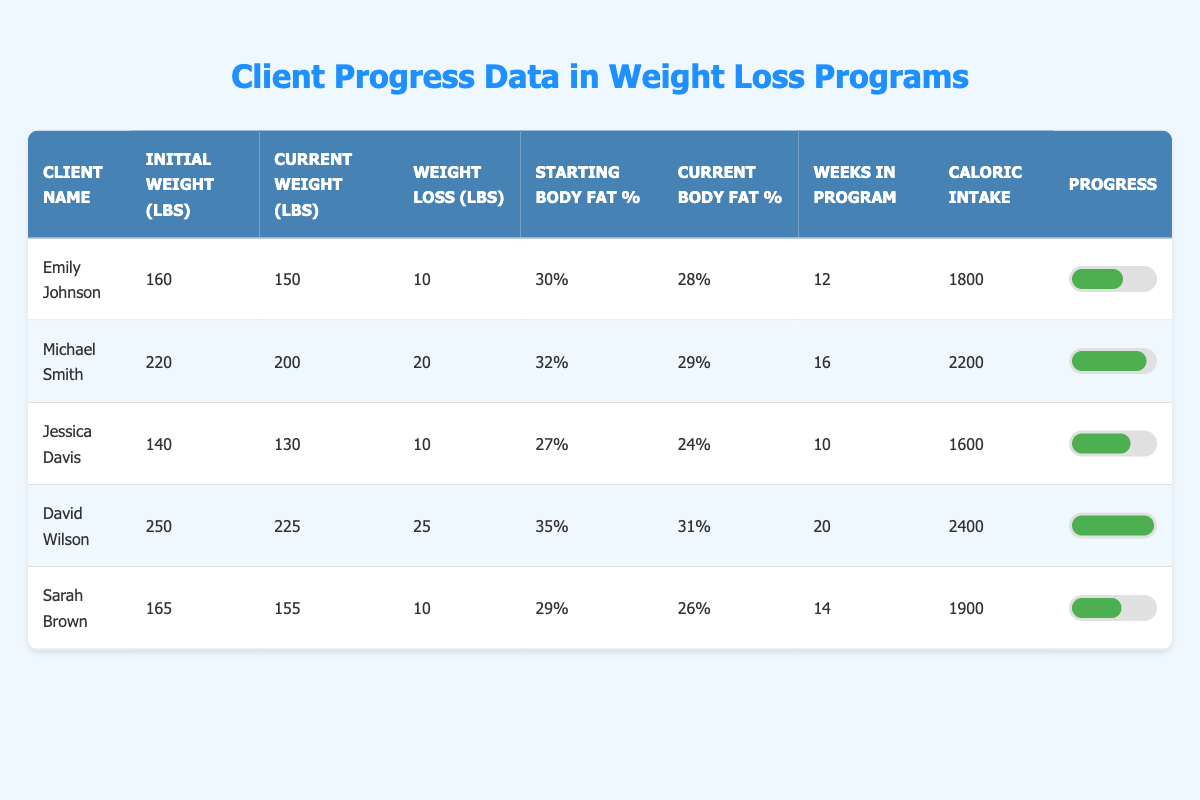What is the current weight of Emily Johnson? Emily Johnson's current weight is listed in the table under the "Current Weight (lbs)" column, which shows 150 lbs.
Answer: 150 How much weight has Michael Smith lost? Michael Smith's weight loss is provided in the "Weight Loss (lbs)" column, where it states he lost a total of 20 lbs.
Answer: 20 What is the average weight loss across all clients? To find the average, we first sum the weight loss from each client: 10 + 20 + 10 + 25 + 10 = 75. Then, we divide that total by the number of clients (5), so 75 / 5 = 15.
Answer: 15 Did any client lose more than 20 pounds? Checking the "Weight Loss (lbs)" column, David Wilson lost 25 lbs, which is indeed more than 20 lbs.
Answer: Yes Which client has the highest starting body fat percentage? Looking at the "Starting Body Fat %" column, David Wilson has the highest percentage listed, which is 35%.
Answer: 35% What is the difference in weeks in the program between the client with the highest and the lowest weight loss? David Wilson has been in the program for 20 weeks and has lost 25 lbs, while Jessica Davis has only been in the program for 10 weeks with a weight loss of 10 lbs. The difference in weeks is 20 - 10 = 10 weeks.
Answer: 10 weeks Which client has the lowest current body fat percentage and what is it? Checking the "Current Body Fat %" column, Jessica Davis shows the lowest body fat percentage at 24%.
Answer: 24% On average, how much caloric intake is consumed by the clients? Summing the caloric intakes: 1800 + 2200 + 1600 + 2400 + 1900 = 10900, then dividing by the number of clients (5), gives us an average intake of 10900 / 5 = 2180.
Answer: 2180 Is the current weight of Sarah Brown less than 160 pounds? Sarah Brown's current weight is found in the table, which shows she weighs 155 lbs, confirming she is indeed less than 160 lbs.
Answer: Yes How much body fat percentage has Emily Johnson reduced? The difference in body fat percentage for Emily Johnson is calculated by subtracting her current body fat from her starting body fat: 30% - 28% = 2%.
Answer: 2% 